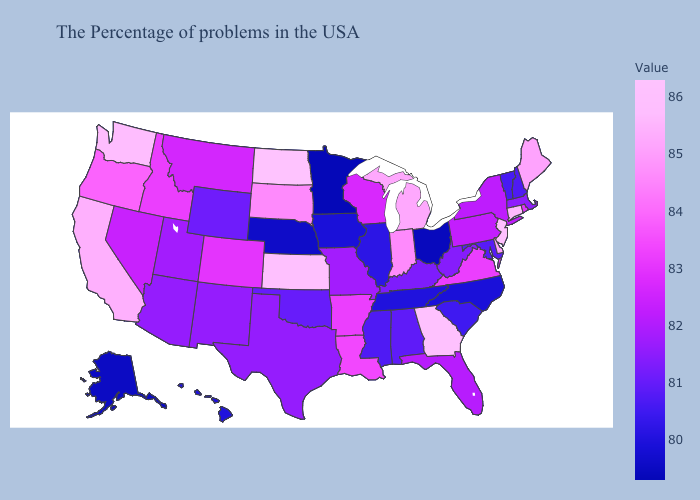Among the states that border Oregon , which have the highest value?
Short answer required. Washington. Does Texas have the highest value in the South?
Answer briefly. No. Is the legend a continuous bar?
Concise answer only. Yes. Does Hawaii have the lowest value in the USA?
Write a very short answer. No. Which states have the highest value in the USA?
Concise answer only. North Dakota. Does North Dakota have the highest value in the USA?
Answer briefly. Yes. Which states have the highest value in the USA?
Be succinct. North Dakota. Does the map have missing data?
Keep it brief. No. 